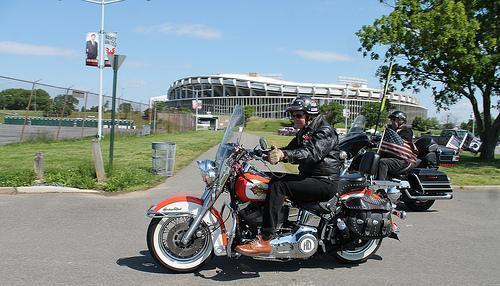How many men are in the photo?
Give a very brief answer. 2. 